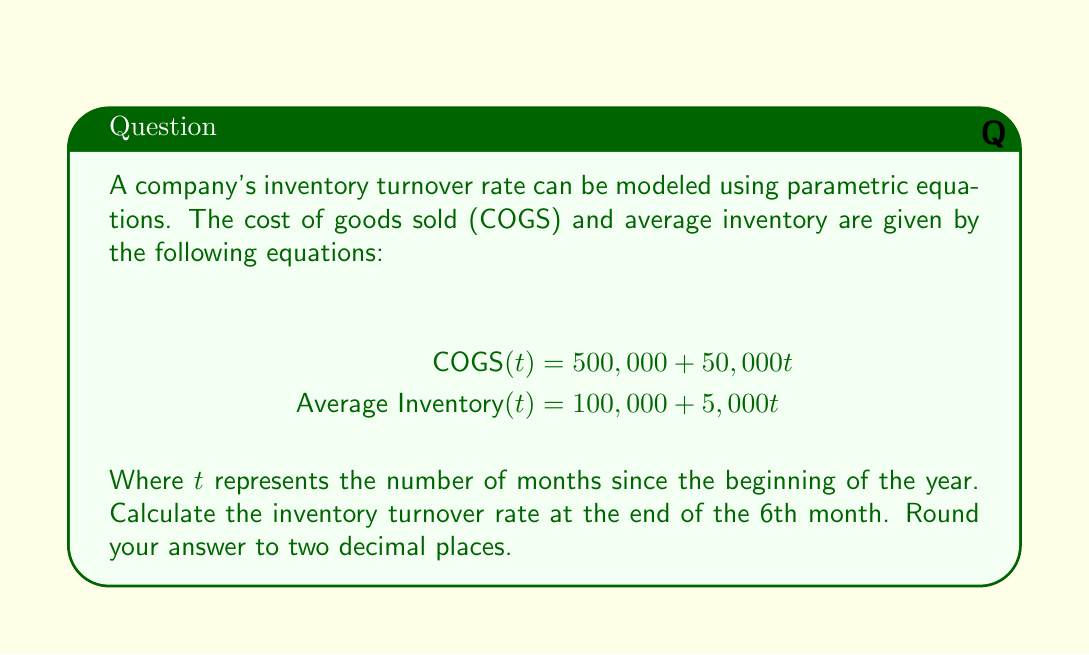Solve this math problem. To solve this problem, we'll follow these steps:

1. Recall the formula for inventory turnover rate:
   $$\text{Inventory Turnover Rate} = \frac{\text{COGS}}{\text{Average Inventory}}$$

2. Substitute $t = 6$ into both parametric equations:
   $$\text{COGS}(6) = 500,000 + 50,000(6) = 500,000 + 300,000 = 800,000$$
   $$\text{Average Inventory}(6) = 100,000 + 5,000(6) = 100,000 + 30,000 = 130,000$$

3. Calculate the inventory turnover rate:
   $$\text{Inventory Turnover Rate} = \frac{800,000}{130,000} \approx 6.1538$$

4. Round the result to two decimal places:
   $$\text{Inventory Turnover Rate} \approx 6.15$$

This rate indicates that the company is turning over its inventory approximately 6.15 times in the given period.
Answer: 6.15 